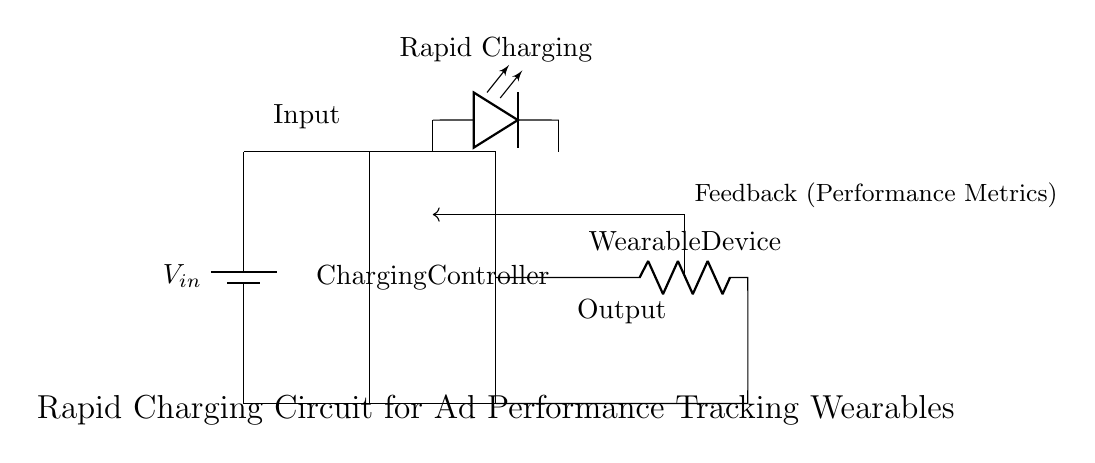What is the type of the power source in this circuit? The power source is a battery, as indicated by the symbol labeled 'V_in' in the circuit diagram. The battery provides the necessary voltage for the circuit operation.
Answer: Battery What does the 'Rapid Charging' indicator represent? The 'Rapid Charging' indicator is a light-emitting diode (LED) that shows when the circuit is in the process of charging rapidly. This is essential for visual feedback to the user regarding the charging status.
Answer: LED What is the role of the Charging Controller? The Charging Controller manages the current flow from the battery to the wearable device, ensuring efficient and safe charging. It regulates the voltage and current to prevent overcharging.
Answer: Management How is data for performance metrics fed back into the circuit? Data is fed back through a feedback loop that connects the output of the wearable device back to the Charging Controller, which allows for monitoring and adjustments based on performance.
Answer: Feedback loop What is the output load in this circuit? The output load is the 'Wearable Device', which is represented in the circuit diagram. This device receives power from the charging circuit for operation.
Answer: Wearable Device What would happen if the 'Rapid Charging' LED is off? If the 'Rapid Charging' LED is off, it indicates that the device is not charging rapidly, which could mean that the charging process is slow or the circuit has an issue.
Answer: Not charging What components are involved in the output connection? The output connection consists of a short connection, a resistor labeled 'Wearable Device', and another short connection leading back to the Charging Controller. This setup delivers power to the wearable device.
Answer: Short, Resistor, Short 